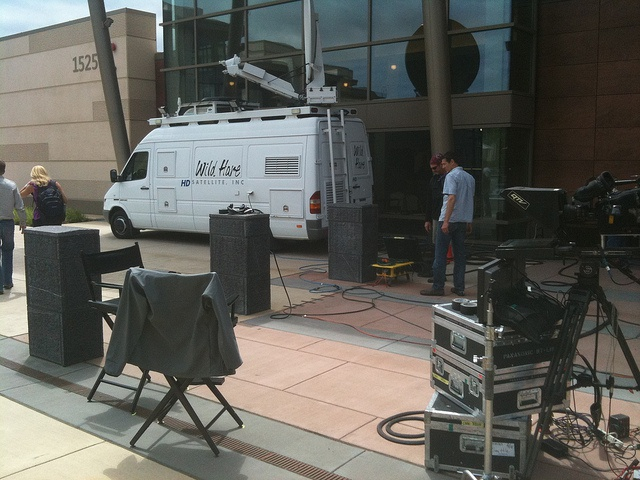Describe the objects in this image and their specific colors. I can see truck in lightblue, darkgray, lightgray, gray, and black tones, chair in lightblue, black, gray, and darkgray tones, people in lightblue, black, gray, and maroon tones, chair in lightblue, black, darkgray, gray, and beige tones, and people in lightblue, gray, black, and darkgray tones in this image. 